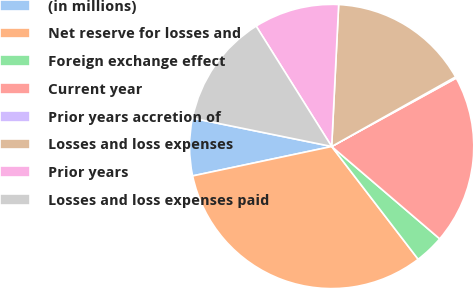Convert chart. <chart><loc_0><loc_0><loc_500><loc_500><pie_chart><fcel>(in millions)<fcel>Net reserve for losses and<fcel>Foreign exchange effect<fcel>Current year<fcel>Prior years accretion of<fcel>Losses and loss expenses<fcel>Prior years<fcel>Losses and loss expenses paid<nl><fcel>6.52%<fcel>32.09%<fcel>3.33%<fcel>19.25%<fcel>0.15%<fcel>16.07%<fcel>9.7%<fcel>12.88%<nl></chart> 